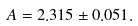<formula> <loc_0><loc_0><loc_500><loc_500>A = 2 . 3 1 5 \pm 0 . 0 5 1 .</formula> 